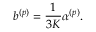<formula> <loc_0><loc_0><loc_500><loc_500>b ^ { ( p ) } = \frac { 1 } { 3 K } \alpha ^ { ( p ) } .</formula> 